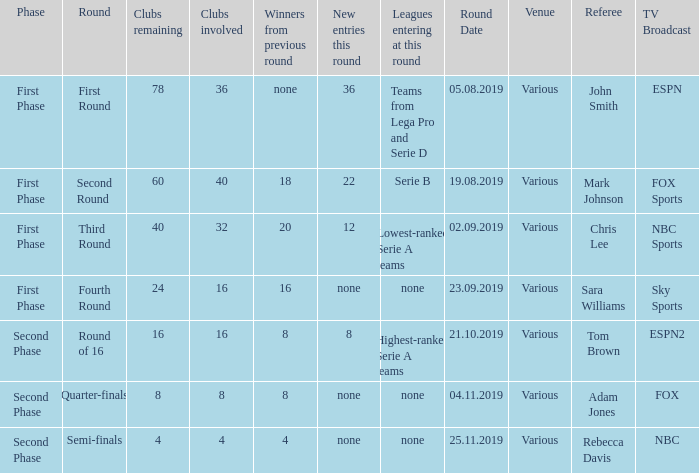When looking at new entries this round and seeing 8; what number in total is there for clubs remaining? 1.0. 